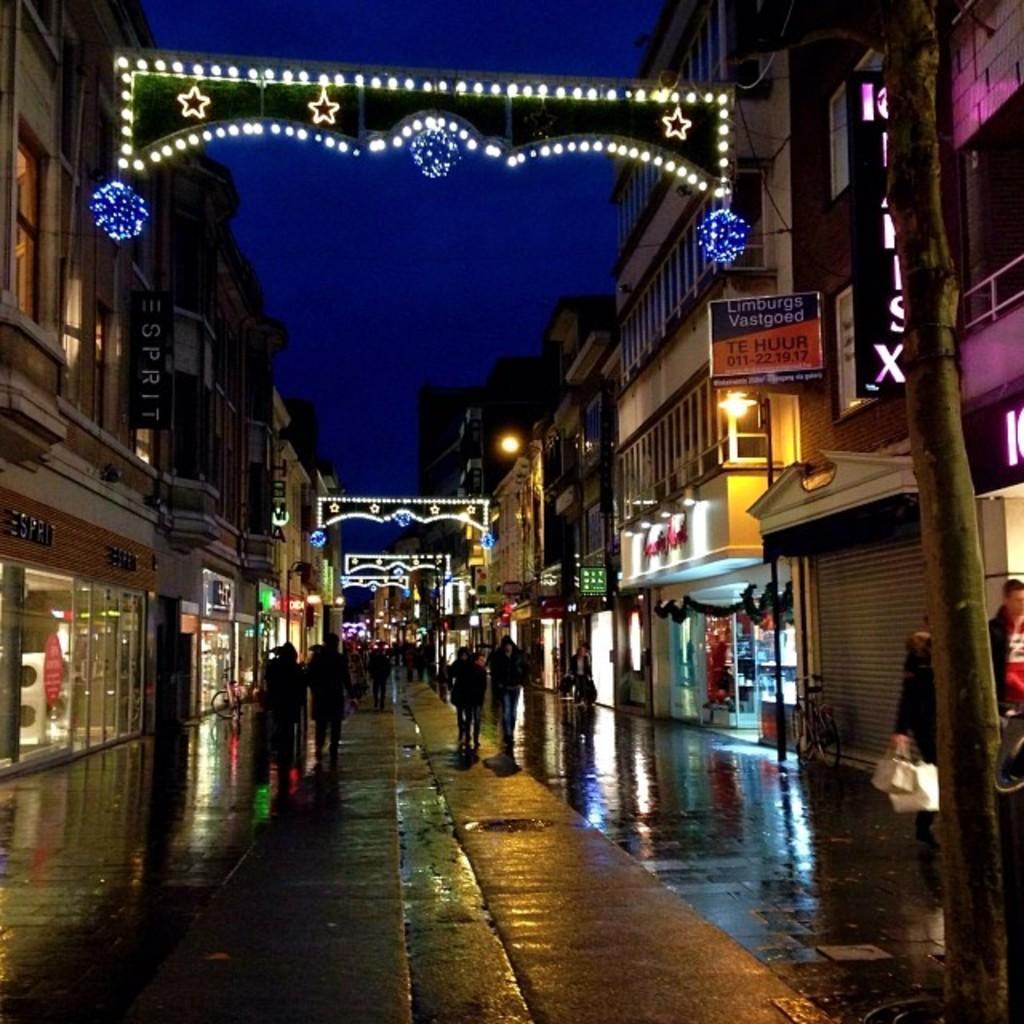In one or two sentences, can you explain what this image depicts? In this image we can see a group of people on the ground. On the right side of the image we can see a person holding bags in his hand and a bicycle parked on the ground. On the left and right side of the image we can see some buildings with windows, lights and board with some text. At the top of the image we can see the sky. 